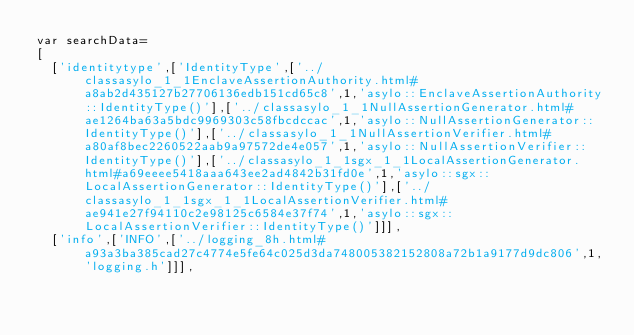Convert code to text. <code><loc_0><loc_0><loc_500><loc_500><_JavaScript_>var searchData=
[
  ['identitytype',['IdentityType',['../classasylo_1_1EnclaveAssertionAuthority.html#a8ab2d435127b27706136edb151cd65c8',1,'asylo::EnclaveAssertionAuthority::IdentityType()'],['../classasylo_1_1NullAssertionGenerator.html#ae1264ba63a5bdc9969303c58fbcdccac',1,'asylo::NullAssertionGenerator::IdentityType()'],['../classasylo_1_1NullAssertionVerifier.html#a80af8bec2260522aab9a97572de4e057',1,'asylo::NullAssertionVerifier::IdentityType()'],['../classasylo_1_1sgx_1_1LocalAssertionGenerator.html#a69eeee5418aaa643ee2ad4842b31fd0e',1,'asylo::sgx::LocalAssertionGenerator::IdentityType()'],['../classasylo_1_1sgx_1_1LocalAssertionVerifier.html#ae941e27f94110c2e98125c6584e37f74',1,'asylo::sgx::LocalAssertionVerifier::IdentityType()']]],
  ['info',['INFO',['../logging_8h.html#a93a3ba385cad27c4774e5fe64c025d3da748005382152808a72b1a9177d9dc806',1,'logging.h']]],</code> 